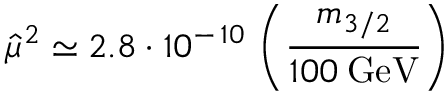<formula> <loc_0><loc_0><loc_500><loc_500>{ \hat { \mu } } ^ { 2 } \simeq 2 . 8 \cdot 1 0 ^ { - \, 1 0 } \, \left ( \frac { m _ { 3 / 2 } } { 1 0 0 \, G e V } \right )</formula> 